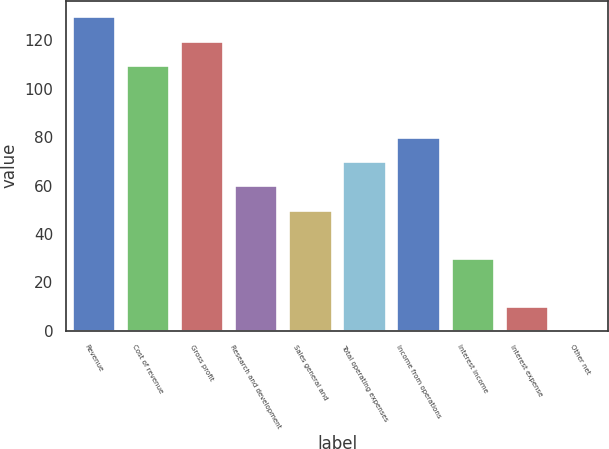<chart> <loc_0><loc_0><loc_500><loc_500><bar_chart><fcel>Revenue<fcel>Cost of revenue<fcel>Gross profit<fcel>Research and development<fcel>Sales general and<fcel>Total operating expenses<fcel>Income from operations<fcel>Interest income<fcel>Interest expense<fcel>Other net<nl><fcel>129.97<fcel>109.99<fcel>119.98<fcel>60.04<fcel>50.05<fcel>70.03<fcel>80.02<fcel>30.07<fcel>10.09<fcel>0.1<nl></chart> 